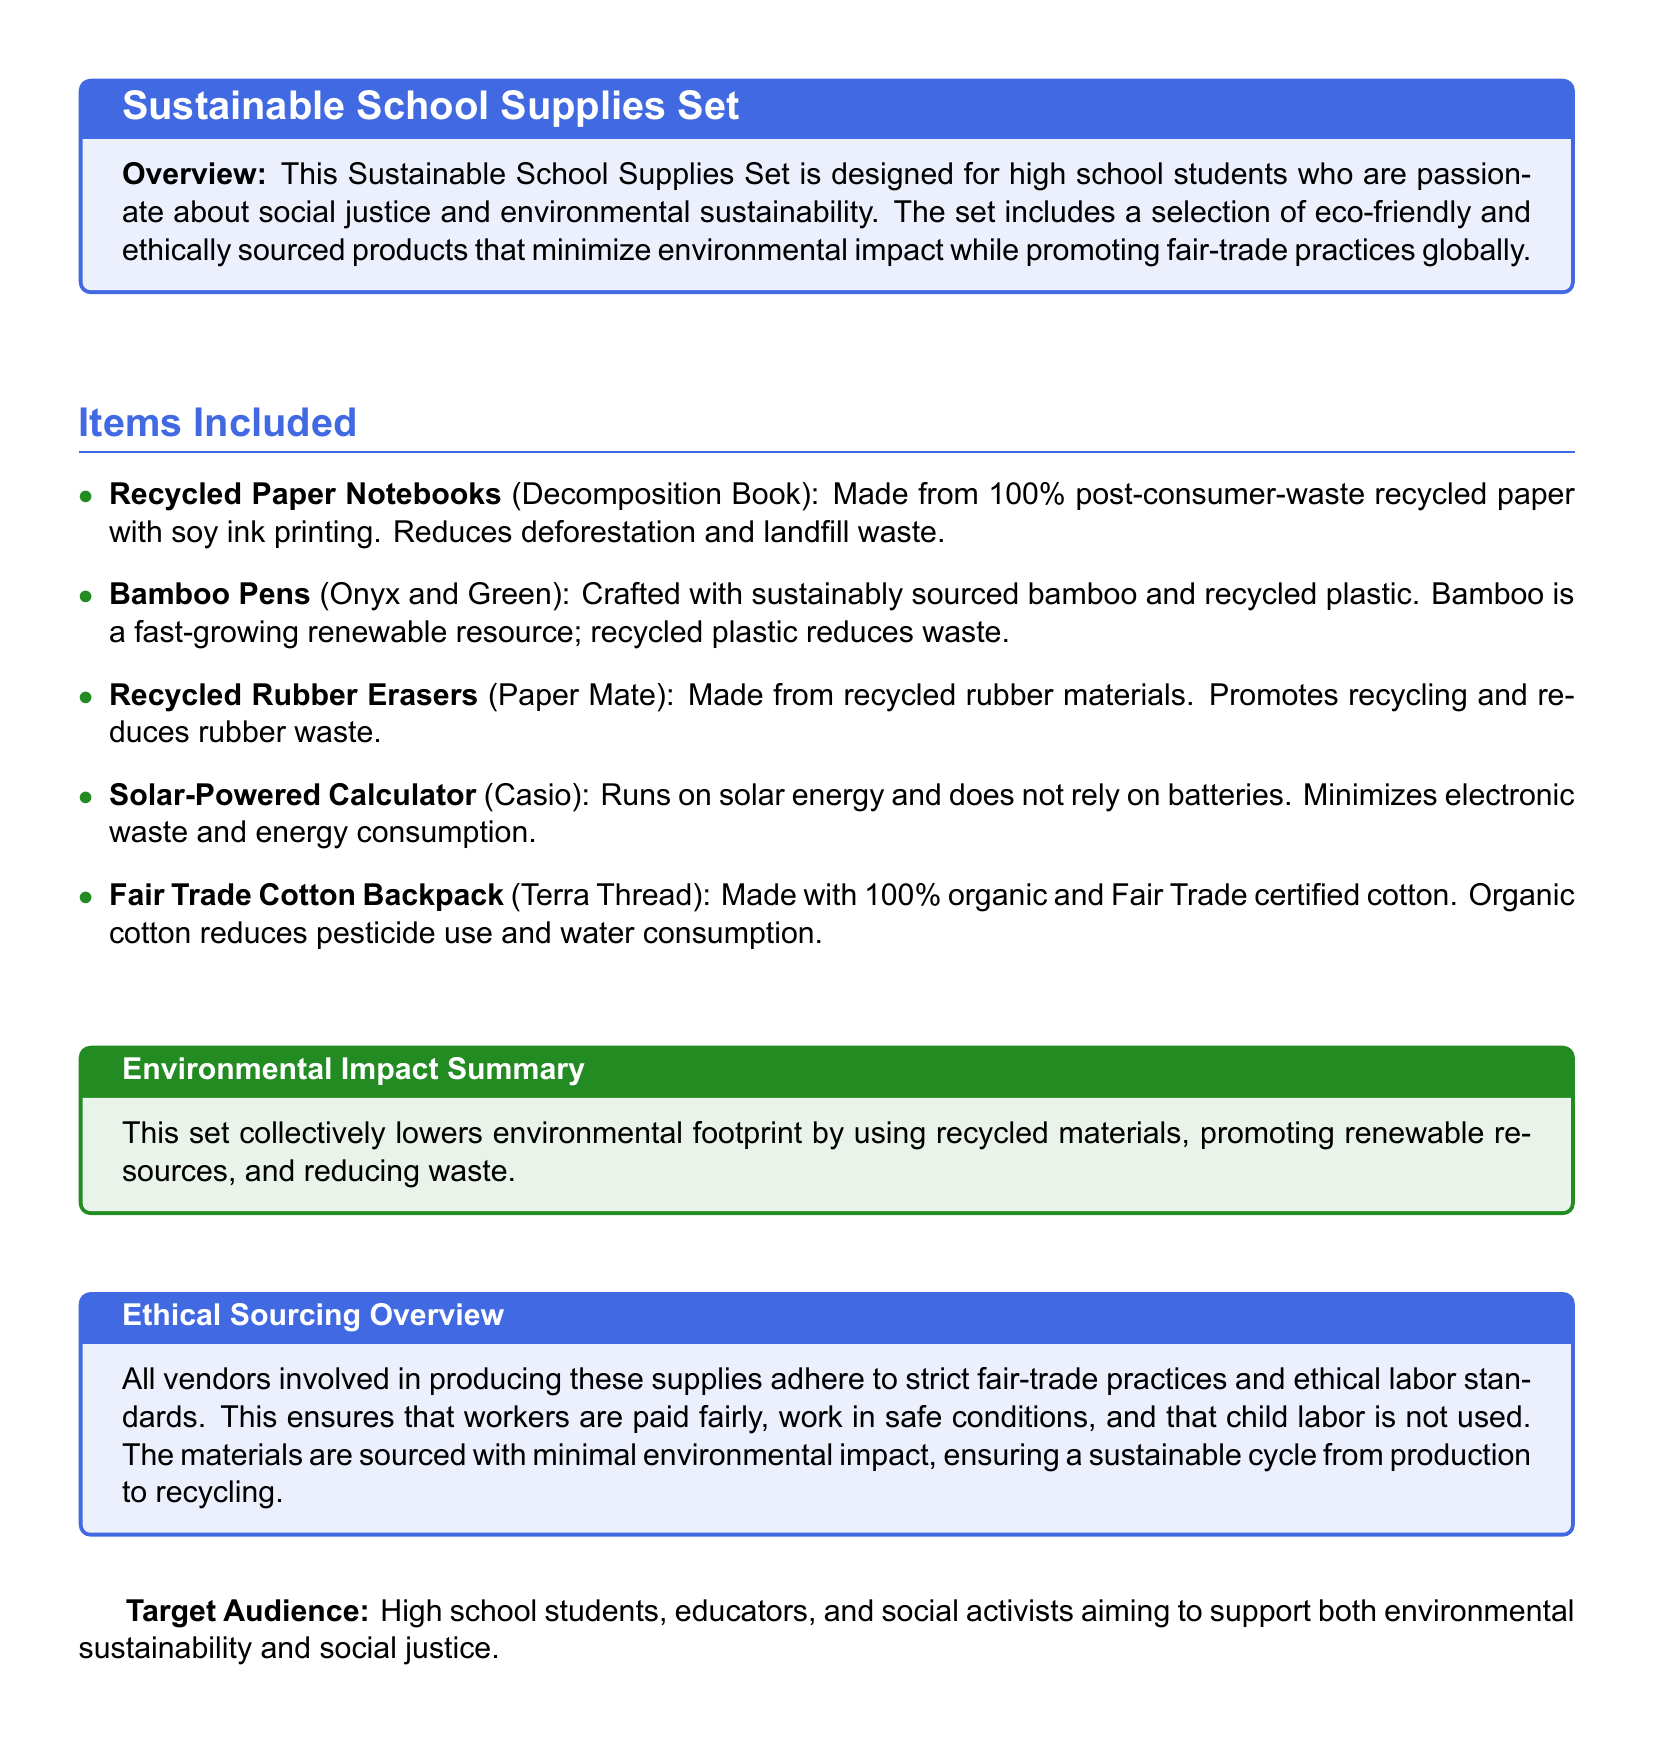What is included in the sustainable school supplies set? The document includes a list of items, such as recycled paper notebooks, bamboo pens, recycled rubber erasers, a solar-powered calculator, and a fair trade cotton backpack.
Answer: Recycled paper notebooks, bamboo pens, recycled rubber erasers, solar-powered calculator, fair trade cotton backpack What percentage of the paper in the notebooks is recycled? The document states that the recycled paper notebooks are made from 100% post-consumer-waste recycled paper.
Answer: 100% What is the main material used in the creation of the bamboo pens? The bamboo pens are crafted from sustainably sourced bamboo, indicating its primary material.
Answer: Bamboo Which vendor's product is crafted from recycled rubber? The document mentions that the recycled rubber erasers are made by Paper Mate, which identifies the vendor.
Answer: Paper Mate What type of energy does the solar-powered calculator rely on? The document specifies that the solar-powered calculator runs on solar energy.
Answer: Solar energy How does the fair trade cotton backpack reduce environmental impact? The document states that the fair trade cotton backpack is made with 100% organic and Fair Trade certified cotton, which reduces pesticide use and water consumption.
Answer: Organic cotton What is the primary target audience for this product? The document explicitly lists high school students, educators, and social activists as the target audience.
Answer: High school students What ethical standard ensures workers are paid fairly? The document refers to strict fair-trade practices adhered to by vendors, which guarantee fair pay for workers.
Answer: Fair-trade practices How does this product set minimize overall environmental footprint? The document mentions that the set collectively lowers environmental footprint by using recycled materials and promoting renewable resources.
Answer: Recycled materials and renewable resources 